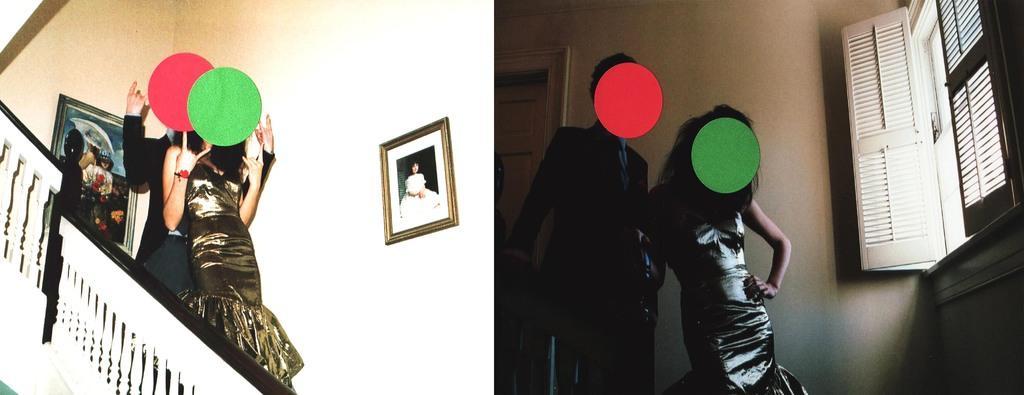Please provide a concise description of this image. This is a collage. On both of the picture there are same person. The man is wearing black suit. The lady is wearing golden dress. On their face red and green color dots are there. In the left both the persons are on staircase. This is the railing. On the wall there are frames. Here in the right there is a window. This is a door. 